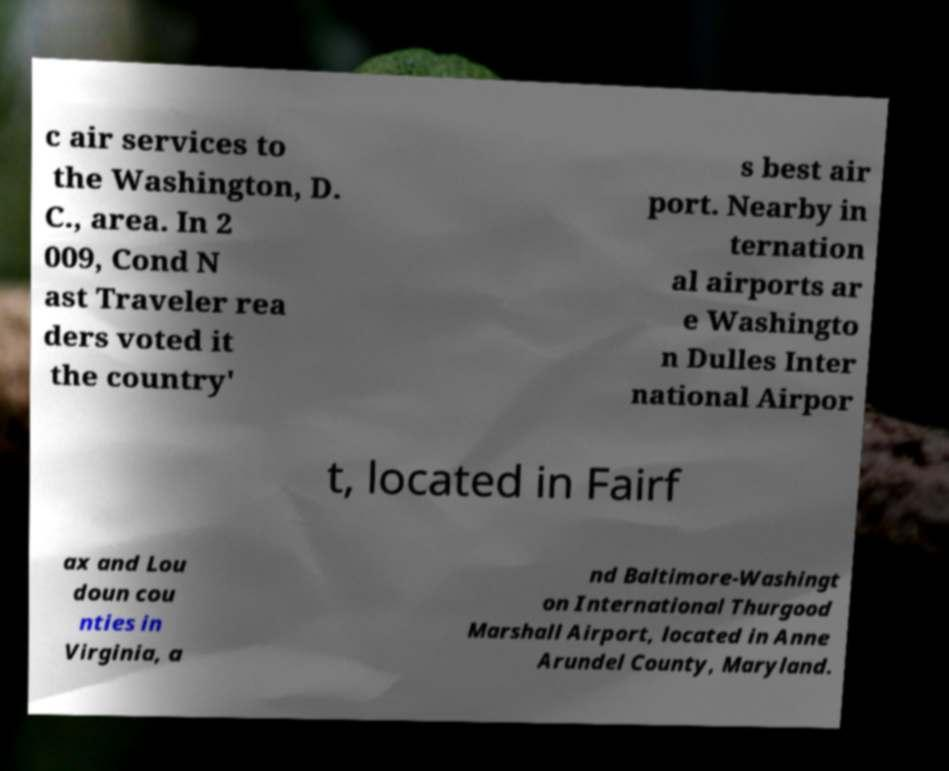Please identify and transcribe the text found in this image. c air services to the Washington, D. C., area. In 2 009, Cond N ast Traveler rea ders voted it the country' s best air port. Nearby in ternation al airports ar e Washingto n Dulles Inter national Airpor t, located in Fairf ax and Lou doun cou nties in Virginia, a nd Baltimore-Washingt on International Thurgood Marshall Airport, located in Anne Arundel County, Maryland. 